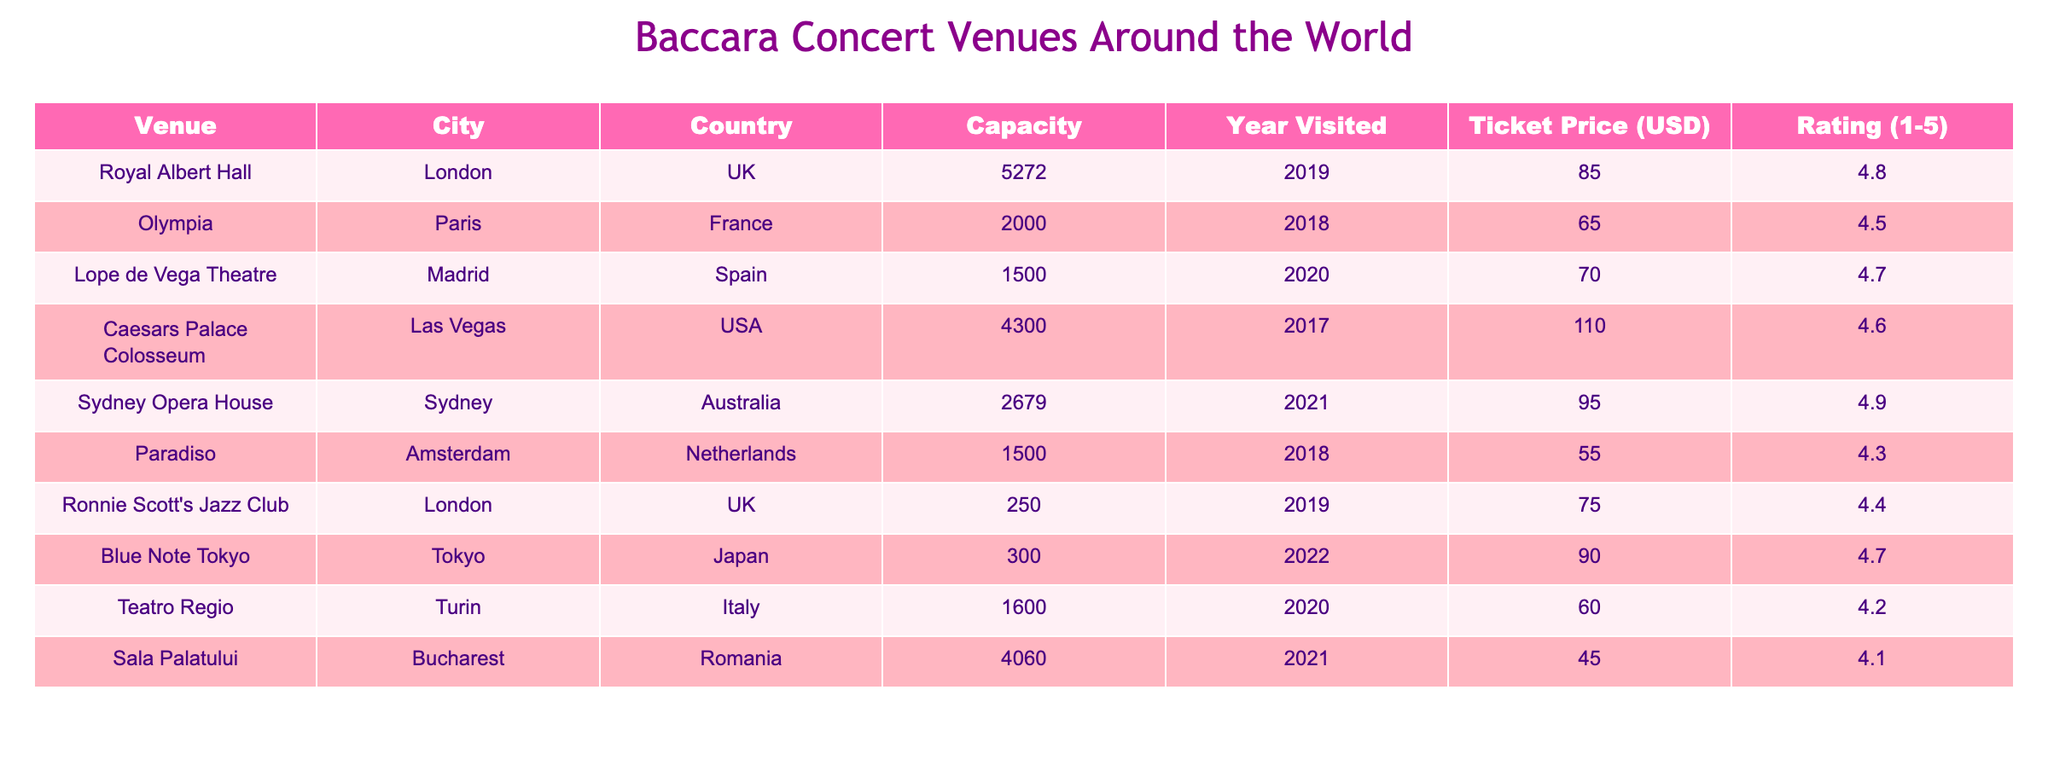What is the highest concert venue capacity on the list? The venue with the highest capacity is the Royal Albert Hall in London, which can hold 5272 attendees.
Answer: 5272 Which city has the lowest ticket price for a Baccara concert? The lowest ticket price is for the Sala Palatului in Bucharest, which is priced at 45 USD.
Answer: 45 What is the average rating of the venues in the table? To find the average rating, sum all the ratings: (4.8 + 4.5 + 4.7 + 4.6 + 4.9 + 4.3 + 4.4 + 4.7 + 4.2 + 4.1) = 46.2. There are 10 venues, so the average rating is 46.2/10 = 4.62.
Answer: 4.62 Is there a venue in a city that has a capacity over 4000? Yes, the Royal Albert Hall in London (5272) and the Caesars Palace Colosseum in Las Vegas (4300) both have capacities over 4000.
Answer: Yes Which venue visited in 2021 has the highest rating? The venue visited in 2021 with the highest rating is the Sydney Opera House, which has a rating of 4.9.
Answer: 4.9 What is the ticket price difference between the highest and lowest priced concerts? The highest ticket price is from Caesars Palace Colosseum at 110 USD, and the lowest is from Sala Palatului at 45 USD. The difference is calculated as 110 - 45 = 65 USD.
Answer: 65 Which city has the most venues listed in this comparison? London has two venues listed: the Royal Albert Hall and Ronnie Scott's Jazz Club, the most for any city in this table.
Answer: London Was there a venue outside of Europe visited in 2019? No, all the venues visited in 2019 (Royal Albert Hall and Ronnie Scott's Jazz Club) are located in Europe.
Answer: No 